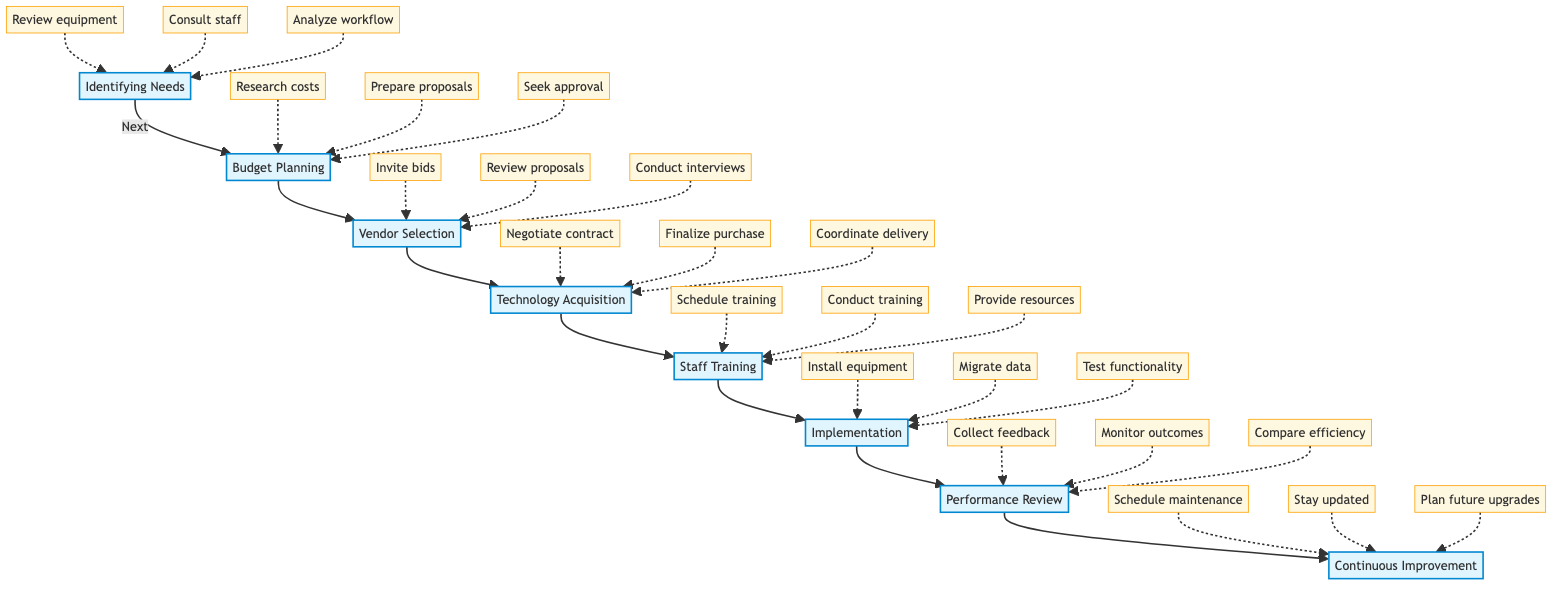What is the first step in the process? The flow chart begins with "Identifying Needs" as the first step in the upgrade planning and implementation process.
Answer: Identifying Needs How many main steps are depicted in the diagram? The diagram shows a total of eight main steps in the upgrade planning and implementation process.
Answer: Eight What is the last step in the process? The process concludes with the step "Continuous Improvement," which emphasizes ongoing enhancements and maintenance.
Answer: Continuous Improvement Which substep follows "Technology Acquisition"? The substep that follows "Technology Acquisition" is "Staff Training," indicating the next action to take after acquiring the technology.
Answer: Staff Training What two steps come before "Performance Review"? The two steps that come before "Performance Review" are "Implementation" and "Staff Training," indicating the sequence prior to evaluating the new technology.
Answer: Implementation and Staff Training How many substeps are identified under "Budget Planning"? There are three substeps listed under "Budget Planning," providing specific actions related to financial planning for the equipment upgrades.
Answer: Three What step has a substep related to staff consultations? The step "Identifying Needs" has substeps that include consulting with the radiology staff for feedback, emphasizing the importance of their input in the decision-making process.
Answer: Identifying Needs Which steps involve assessing performance? The steps "Performance Review" and "Continuous Improvement" both involve assessing performance, highlighting the need for evaluation and ongoing adjustments after implementation.
Answer: Performance Review and Continuous Improvement What is the purpose of the "Technology Acquisition" step? The purpose of the "Technology Acquisition" step is to purchase and acquire the chosen radiological technology through proper negotiation and coordination.
Answer: Purchase and acquire new technology 